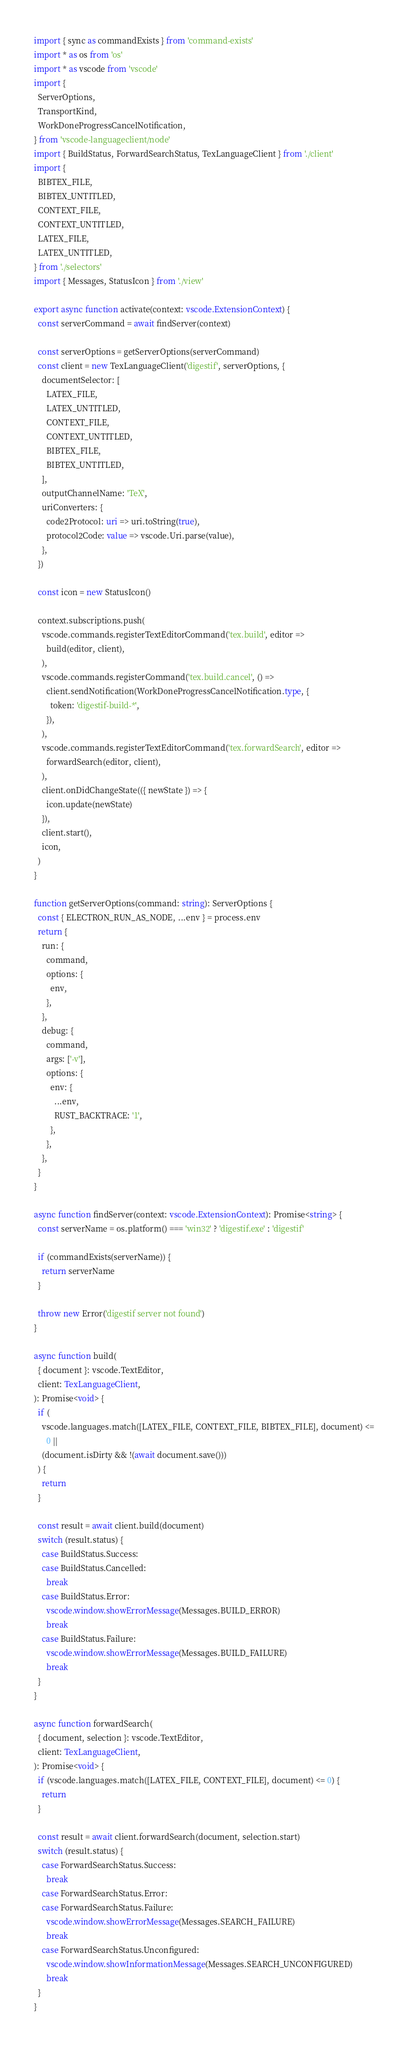<code> <loc_0><loc_0><loc_500><loc_500><_TypeScript_>import { sync as commandExists } from 'command-exists'
import * as os from 'os'
import * as vscode from 'vscode'
import {
  ServerOptions,
  TransportKind,
  WorkDoneProgressCancelNotification,
} from 'vscode-languageclient/node'
import { BuildStatus, ForwardSearchStatus, TexLanguageClient } from './client'
import {
  BIBTEX_FILE,
  BIBTEX_UNTITLED,
  CONTEXT_FILE,
  CONTEXT_UNTITLED,
  LATEX_FILE,
  LATEX_UNTITLED,
} from './selectors'
import { Messages, StatusIcon } from './view'

export async function activate(context: vscode.ExtensionContext) {
  const serverCommand = await findServer(context)

  const serverOptions = getServerOptions(serverCommand)
  const client = new TexLanguageClient('digestif', serverOptions, {
    documentSelector: [
      LATEX_FILE,
      LATEX_UNTITLED,
      CONTEXT_FILE,
      CONTEXT_UNTITLED,
      BIBTEX_FILE,
      BIBTEX_UNTITLED,
    ],
    outputChannelName: 'TeX',
    uriConverters: {
      code2Protocol: uri => uri.toString(true),
      protocol2Code: value => vscode.Uri.parse(value),
    },
  })

  const icon = new StatusIcon()

  context.subscriptions.push(
    vscode.commands.registerTextEditorCommand('tex.build', editor =>
      build(editor, client),
    ),
    vscode.commands.registerCommand('tex.build.cancel', () =>
      client.sendNotification(WorkDoneProgressCancelNotification.type, {
        token: 'digestif-build-*',
      }),
    ),
    vscode.commands.registerTextEditorCommand('tex.forwardSearch', editor =>
      forwardSearch(editor, client),
    ),
    client.onDidChangeState(({ newState }) => {
      icon.update(newState)
    }),
    client.start(),
    icon,
  )
}

function getServerOptions(command: string): ServerOptions {
  const { ELECTRON_RUN_AS_NODE, ...env } = process.env
  return {
    run: {
      command,
      options: {
        env,
      },
    },
    debug: {
      command,
      args: ['-v'],
      options: {
        env: {
          ...env,
          RUST_BACKTRACE: '1',
        },
      },
    },
  }
}

async function findServer(context: vscode.ExtensionContext): Promise<string> {
  const serverName = os.platform() === 'win32' ? 'digestif.exe' : 'digestif'

  if (commandExists(serverName)) {
    return serverName
  }

  throw new Error('digestif server not found')
}

async function build(
  { document }: vscode.TextEditor,
  client: TexLanguageClient,
): Promise<void> {
  if (
    vscode.languages.match([LATEX_FILE, CONTEXT_FILE, BIBTEX_FILE], document) <=
      0 ||
    (document.isDirty && !(await document.save()))
  ) {
    return
  }

  const result = await client.build(document)
  switch (result.status) {
    case BuildStatus.Success:
    case BuildStatus.Cancelled:
      break
    case BuildStatus.Error:
      vscode.window.showErrorMessage(Messages.BUILD_ERROR)
      break
    case BuildStatus.Failure:
      vscode.window.showErrorMessage(Messages.BUILD_FAILURE)
      break
  }
}

async function forwardSearch(
  { document, selection }: vscode.TextEditor,
  client: TexLanguageClient,
): Promise<void> {
  if (vscode.languages.match([LATEX_FILE, CONTEXT_FILE], document) <= 0) {
    return
  }

  const result = await client.forwardSearch(document, selection.start)
  switch (result.status) {
    case ForwardSearchStatus.Success:
      break
    case ForwardSearchStatus.Error:
    case ForwardSearchStatus.Failure:
      vscode.window.showErrorMessage(Messages.SEARCH_FAILURE)
      break
    case ForwardSearchStatus.Unconfigured:
      vscode.window.showInformationMessage(Messages.SEARCH_UNCONFIGURED)
      break
  }
}
</code> 